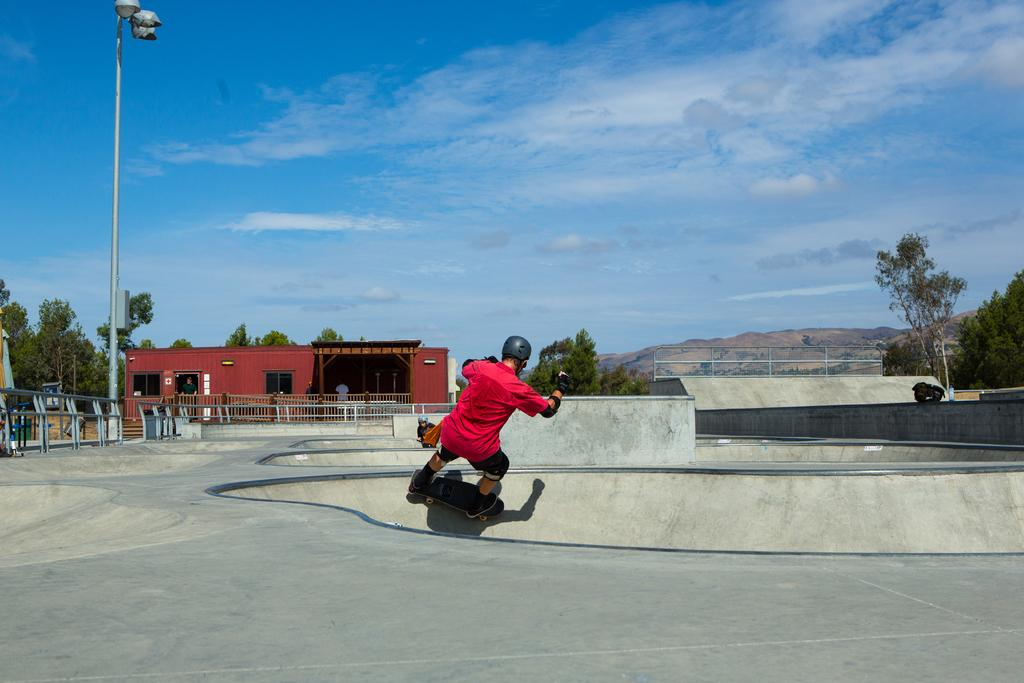What is the person in the image doing? The person is skating on a skateboard in the image. What can be seen in the background of the image? There is a fence, trees, a building, and mountains in the background of the image. How many pizzas is the person in the image distributing? There are no pizzas or distribution present in the image. 